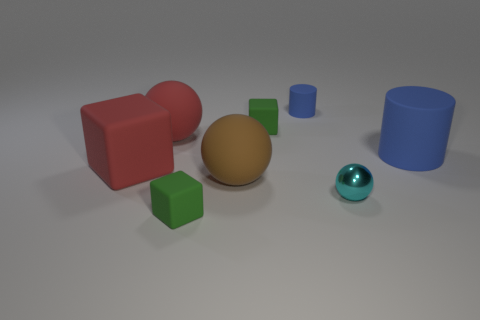Does the brown rubber ball have the same size as the cyan shiny sphere?
Make the answer very short. No. Is there a small red rubber block?
Ensure brevity in your answer.  No. There is another matte cylinder that is the same color as the big matte cylinder; what is its size?
Ensure brevity in your answer.  Small. There is a red matte object that is in front of the ball left of the tiny rubber block that is in front of the large red block; what size is it?
Give a very brief answer. Large. How many brown objects have the same material as the red cube?
Your response must be concise. 1. What number of other brown spheres have the same size as the metallic sphere?
Make the answer very short. 0. What is the cylinder to the right of the small matte thing that is behind the green thing that is behind the tiny cyan metal object made of?
Your answer should be very brief. Rubber. What number of objects are big red matte spheres or tiny red rubber blocks?
Offer a terse response. 1. Is there anything else that is made of the same material as the cyan sphere?
Your answer should be very brief. No. What is the shape of the tiny cyan object?
Make the answer very short. Sphere. 